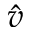Convert formula to latex. <formula><loc_0><loc_0><loc_500><loc_500>\hat { v }</formula> 